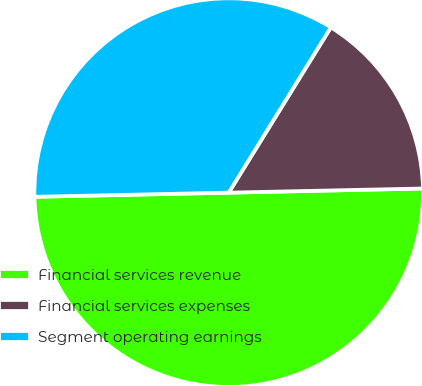Convert chart. <chart><loc_0><loc_0><loc_500><loc_500><pie_chart><fcel>Financial services revenue<fcel>Financial services expenses<fcel>Segment operating earnings<nl><fcel>50.0%<fcel>15.85%<fcel>34.15%<nl></chart> 